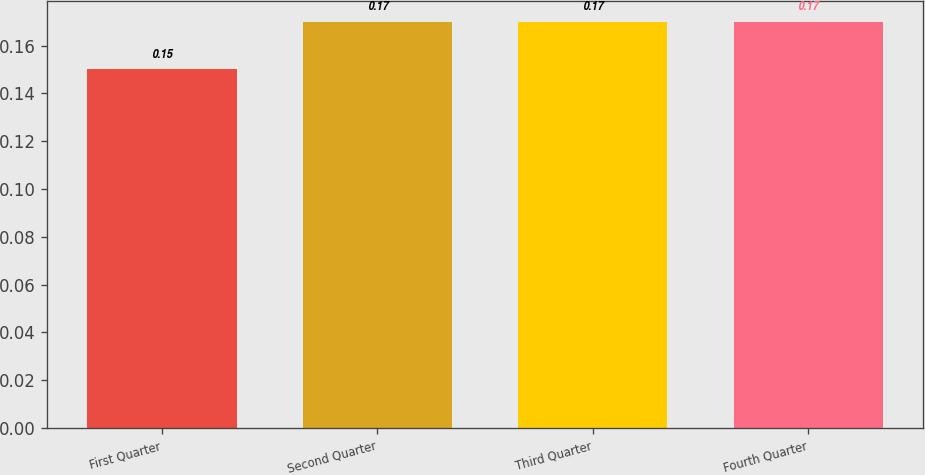<chart> <loc_0><loc_0><loc_500><loc_500><bar_chart><fcel>First Quarter<fcel>Second Quarter<fcel>Third Quarter<fcel>Fourth Quarter<nl><fcel>0.15<fcel>0.17<fcel>0.17<fcel>0.17<nl></chart> 